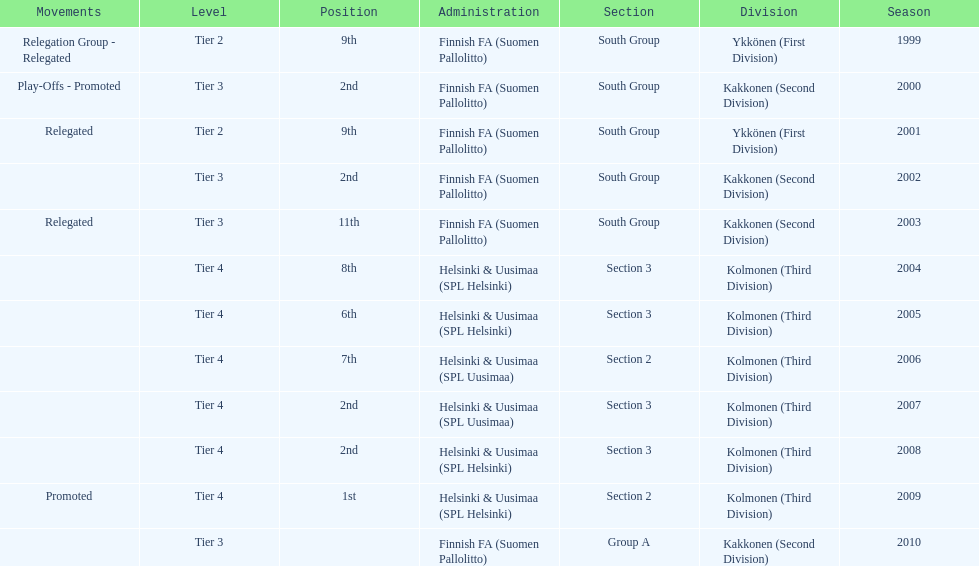What division were they in the most, section 3 or 2? 3. Parse the table in full. {'header': ['Movements', 'Level', 'Position', 'Administration', 'Section', 'Division', 'Season'], 'rows': [['Relegation Group - Relegated', 'Tier 2', '9th', 'Finnish FA (Suomen Pallolitto)', 'South Group', 'Ykkönen (First Division)', '1999'], ['Play-Offs - Promoted', 'Tier 3', '2nd', 'Finnish FA (Suomen Pallolitto)', 'South Group', 'Kakkonen (Second Division)', '2000'], ['Relegated', 'Tier 2', '9th', 'Finnish FA (Suomen Pallolitto)', 'South Group', 'Ykkönen (First Division)', '2001'], ['', 'Tier 3', '2nd', 'Finnish FA (Suomen Pallolitto)', 'South Group', 'Kakkonen (Second Division)', '2002'], ['Relegated', 'Tier 3', '11th', 'Finnish FA (Suomen Pallolitto)', 'South Group', 'Kakkonen (Second Division)', '2003'], ['', 'Tier 4', '8th', 'Helsinki & Uusimaa (SPL Helsinki)', 'Section 3', 'Kolmonen (Third Division)', '2004'], ['', 'Tier 4', '6th', 'Helsinki & Uusimaa (SPL Helsinki)', 'Section 3', 'Kolmonen (Third Division)', '2005'], ['', 'Tier 4', '7th', 'Helsinki & Uusimaa (SPL Uusimaa)', 'Section 2', 'Kolmonen (Third Division)', '2006'], ['', 'Tier 4', '2nd', 'Helsinki & Uusimaa (SPL Uusimaa)', 'Section 3', 'Kolmonen (Third Division)', '2007'], ['', 'Tier 4', '2nd', 'Helsinki & Uusimaa (SPL Helsinki)', 'Section 3', 'Kolmonen (Third Division)', '2008'], ['Promoted', 'Tier 4', '1st', 'Helsinki & Uusimaa (SPL Helsinki)', 'Section 2', 'Kolmonen (Third Division)', '2009'], ['', 'Tier 3', '', 'Finnish FA (Suomen Pallolitto)', 'Group A', 'Kakkonen (Second Division)', '2010']]} 